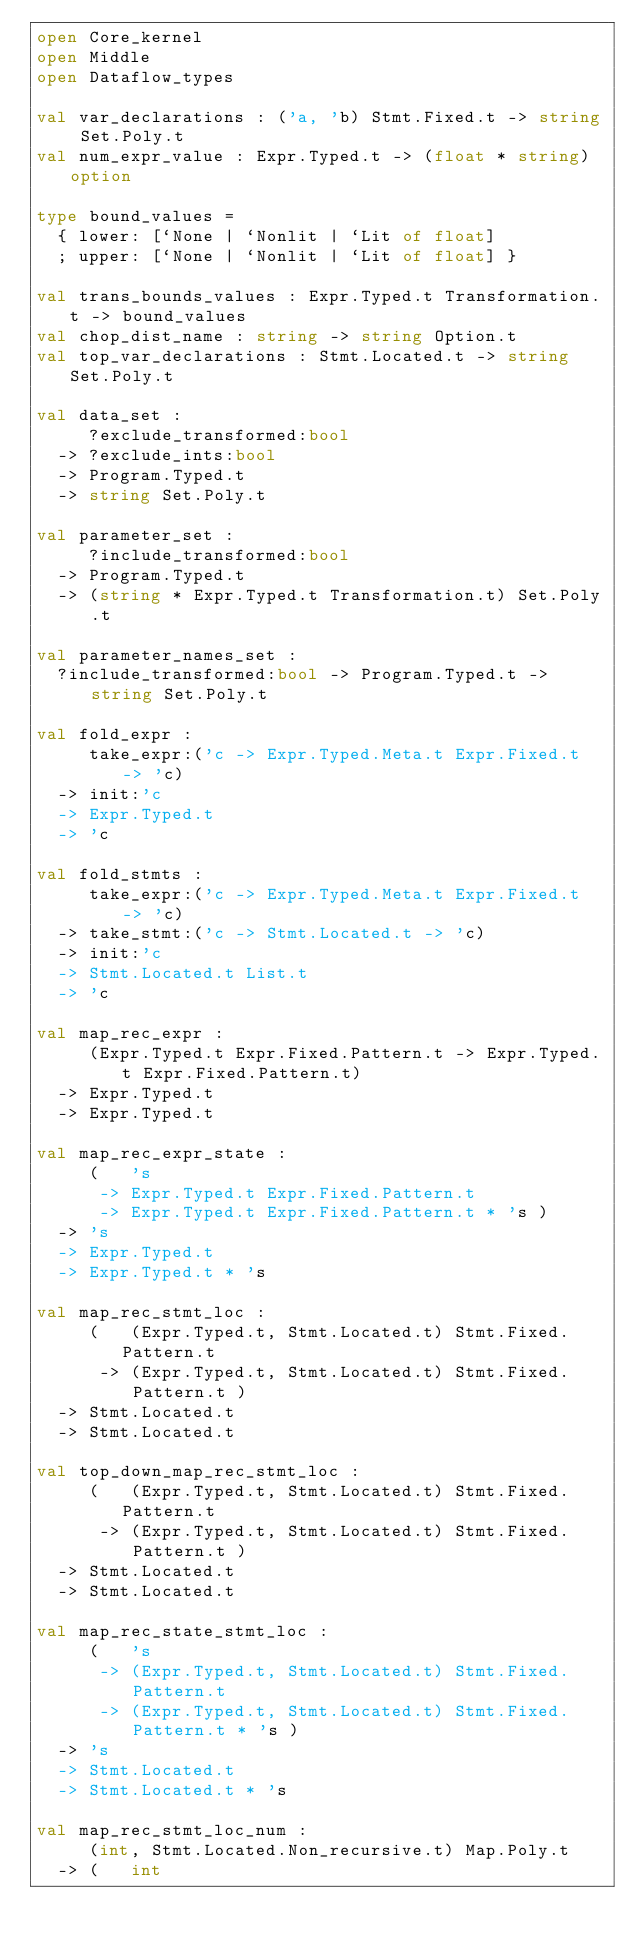Convert code to text. <code><loc_0><loc_0><loc_500><loc_500><_OCaml_>open Core_kernel
open Middle
open Dataflow_types

val var_declarations : ('a, 'b) Stmt.Fixed.t -> string Set.Poly.t
val num_expr_value : Expr.Typed.t -> (float * string) option

type bound_values =
  { lower: [`None | `Nonlit | `Lit of float]
  ; upper: [`None | `Nonlit | `Lit of float] }

val trans_bounds_values : Expr.Typed.t Transformation.t -> bound_values
val chop_dist_name : string -> string Option.t
val top_var_declarations : Stmt.Located.t -> string Set.Poly.t

val data_set :
     ?exclude_transformed:bool
  -> ?exclude_ints:bool
  -> Program.Typed.t
  -> string Set.Poly.t

val parameter_set :
     ?include_transformed:bool
  -> Program.Typed.t
  -> (string * Expr.Typed.t Transformation.t) Set.Poly.t

val parameter_names_set :
  ?include_transformed:bool -> Program.Typed.t -> string Set.Poly.t

val fold_expr :
     take_expr:('c -> Expr.Typed.Meta.t Expr.Fixed.t -> 'c)
  -> init:'c
  -> Expr.Typed.t
  -> 'c

val fold_stmts :
     take_expr:('c -> Expr.Typed.Meta.t Expr.Fixed.t -> 'c)
  -> take_stmt:('c -> Stmt.Located.t -> 'c)
  -> init:'c
  -> Stmt.Located.t List.t
  -> 'c

val map_rec_expr :
     (Expr.Typed.t Expr.Fixed.Pattern.t -> Expr.Typed.t Expr.Fixed.Pattern.t)
  -> Expr.Typed.t
  -> Expr.Typed.t

val map_rec_expr_state :
     (   's
      -> Expr.Typed.t Expr.Fixed.Pattern.t
      -> Expr.Typed.t Expr.Fixed.Pattern.t * 's )
  -> 's
  -> Expr.Typed.t
  -> Expr.Typed.t * 's

val map_rec_stmt_loc :
     (   (Expr.Typed.t, Stmt.Located.t) Stmt.Fixed.Pattern.t
      -> (Expr.Typed.t, Stmt.Located.t) Stmt.Fixed.Pattern.t )
  -> Stmt.Located.t
  -> Stmt.Located.t

val top_down_map_rec_stmt_loc :
     (   (Expr.Typed.t, Stmt.Located.t) Stmt.Fixed.Pattern.t
      -> (Expr.Typed.t, Stmt.Located.t) Stmt.Fixed.Pattern.t )
  -> Stmt.Located.t
  -> Stmt.Located.t

val map_rec_state_stmt_loc :
     (   's
      -> (Expr.Typed.t, Stmt.Located.t) Stmt.Fixed.Pattern.t
      -> (Expr.Typed.t, Stmt.Located.t) Stmt.Fixed.Pattern.t * 's )
  -> 's
  -> Stmt.Located.t
  -> Stmt.Located.t * 's

val map_rec_stmt_loc_num :
     (int, Stmt.Located.Non_recursive.t) Map.Poly.t
  -> (   int</code> 